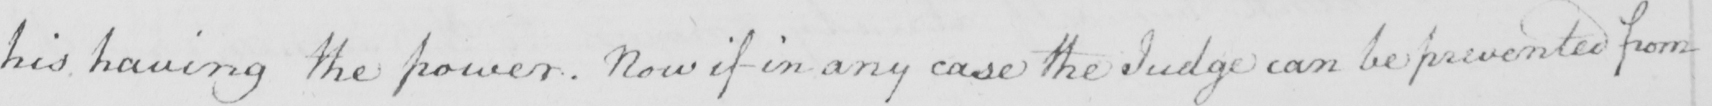Can you tell me what this handwritten text says? his having the power . Now if in any case the Judge can be prevented from 